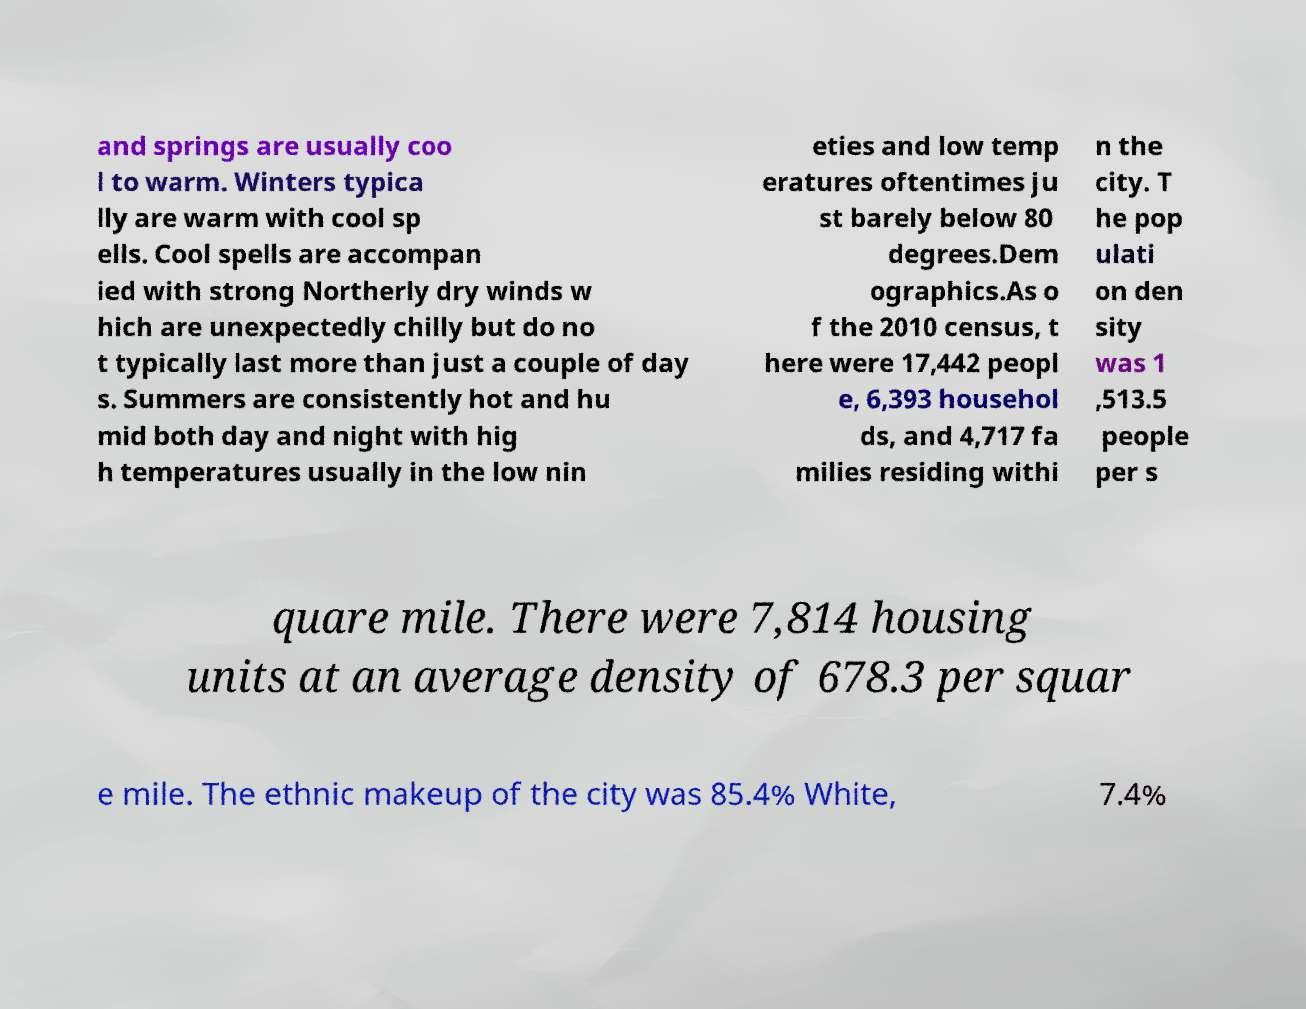I need the written content from this picture converted into text. Can you do that? and springs are usually coo l to warm. Winters typica lly are warm with cool sp ells. Cool spells are accompan ied with strong Northerly dry winds w hich are unexpectedly chilly but do no t typically last more than just a couple of day s. Summers are consistently hot and hu mid both day and night with hig h temperatures usually in the low nin eties and low temp eratures oftentimes ju st barely below 80 degrees.Dem ographics.As o f the 2010 census, t here were 17,442 peopl e, 6,393 househol ds, and 4,717 fa milies residing withi n the city. T he pop ulati on den sity was 1 ,513.5 people per s quare mile. There were 7,814 housing units at an average density of 678.3 per squar e mile. The ethnic makeup of the city was 85.4% White, 7.4% 